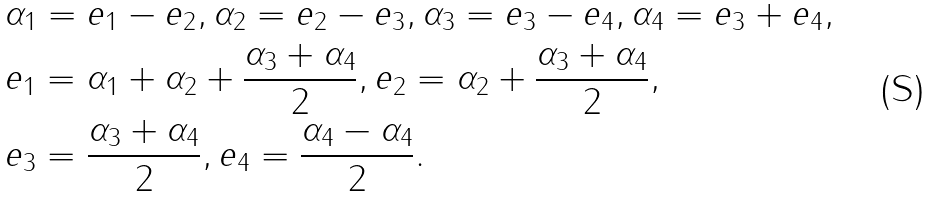Convert formula to latex. <formula><loc_0><loc_0><loc_500><loc_500>& \alpha _ { 1 } = e _ { 1 } - e _ { 2 } , \alpha _ { 2 } = e _ { 2 } - e _ { 3 } , \alpha _ { 3 } = e _ { 3 } - e _ { 4 } , \alpha _ { 4 } = e _ { 3 } + e _ { 4 } , \\ & e _ { 1 } = \alpha _ { 1 } + \alpha _ { 2 } + \frac { \alpha _ { 3 } + \alpha _ { 4 } } { 2 } , e _ { 2 } = \alpha _ { 2 } + \frac { \alpha _ { 3 } + \alpha _ { 4 } } { 2 } , \\ & e _ { 3 } = \frac { \alpha _ { 3 } + \alpha _ { 4 } } { 2 } , e _ { 4 } = \frac { \alpha _ { 4 } - \alpha _ { 4 } } { 2 } .</formula> 